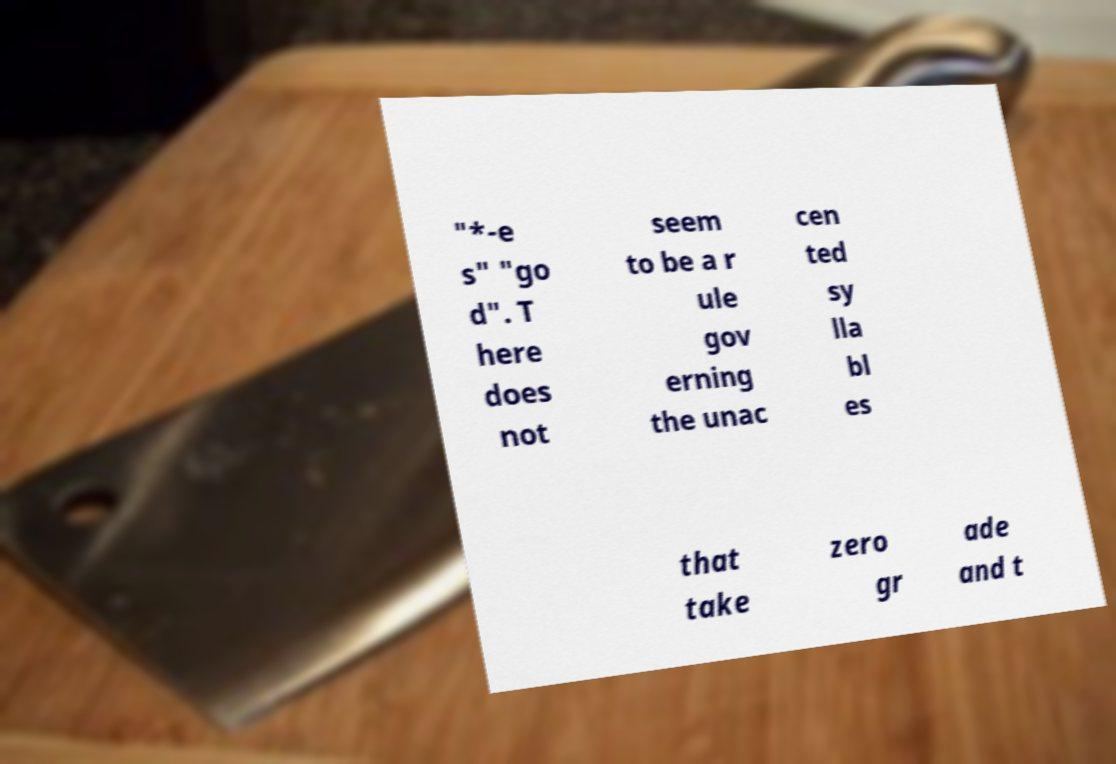Please read and relay the text visible in this image. What does it say? "*-e s" "go d". T here does not seem to be a r ule gov erning the unac cen ted sy lla bl es that take zero gr ade and t 